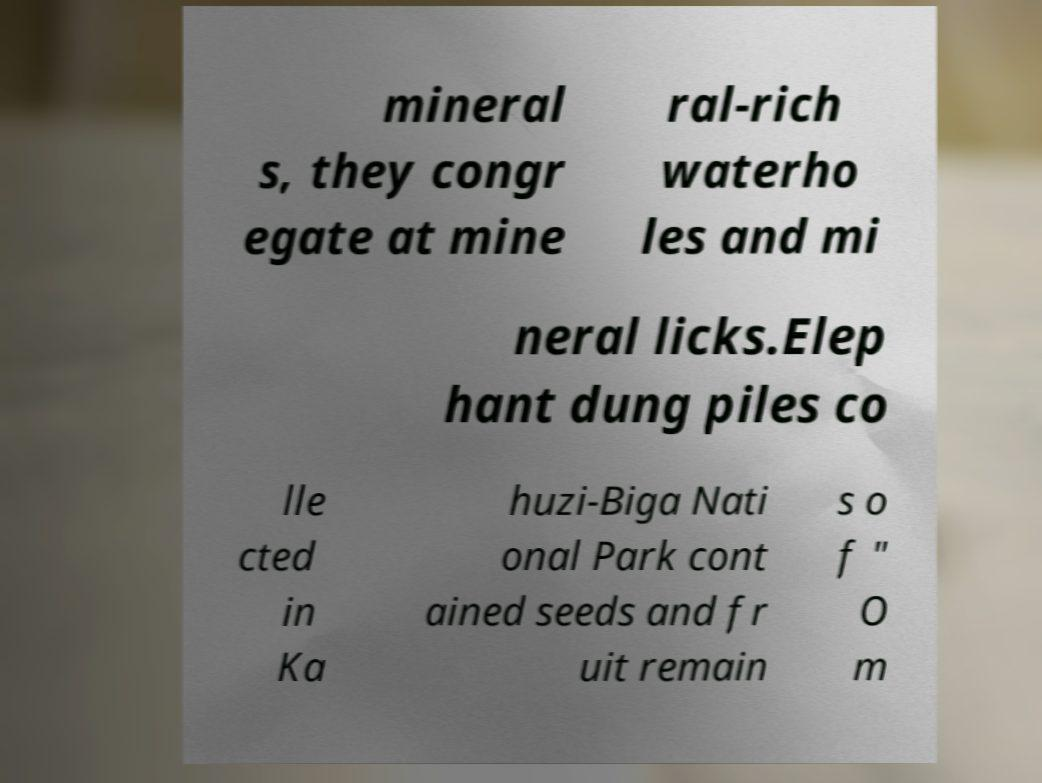Could you extract and type out the text from this image? mineral s, they congr egate at mine ral-rich waterho les and mi neral licks.Elep hant dung piles co lle cted in Ka huzi-Biga Nati onal Park cont ained seeds and fr uit remain s o f " O m 